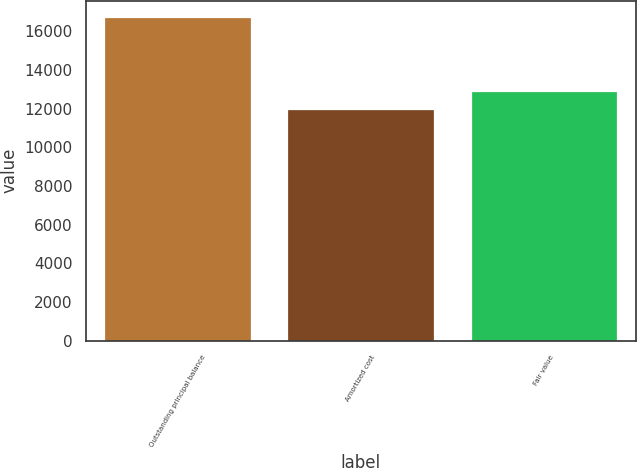Convert chart. <chart><loc_0><loc_0><loc_500><loc_500><bar_chart><fcel>Outstanding principal balance<fcel>Amortized cost<fcel>Fair value<nl><fcel>16728<fcel>11987<fcel>12922<nl></chart> 